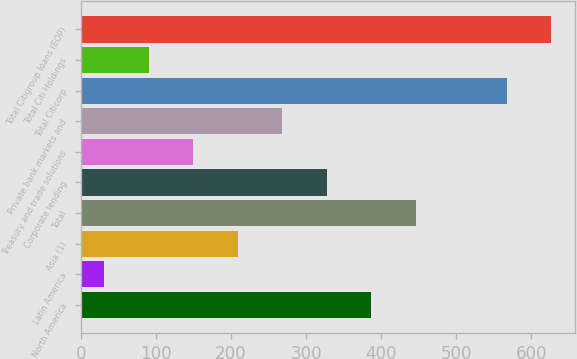<chart> <loc_0><loc_0><loc_500><loc_500><bar_chart><fcel>North America<fcel>Latin America<fcel>Asia (1)<fcel>Total<fcel>Corporate lending<fcel>Treasury and trade solutions<fcel>Private bank markets and<fcel>Total Citicorp<fcel>Total Citi Holdings<fcel>Total Citigroup loans (EOP)<nl><fcel>386.48<fcel>31.4<fcel>208.94<fcel>445.66<fcel>327.3<fcel>149.76<fcel>268.12<fcel>567.1<fcel>90.58<fcel>626.28<nl></chart> 